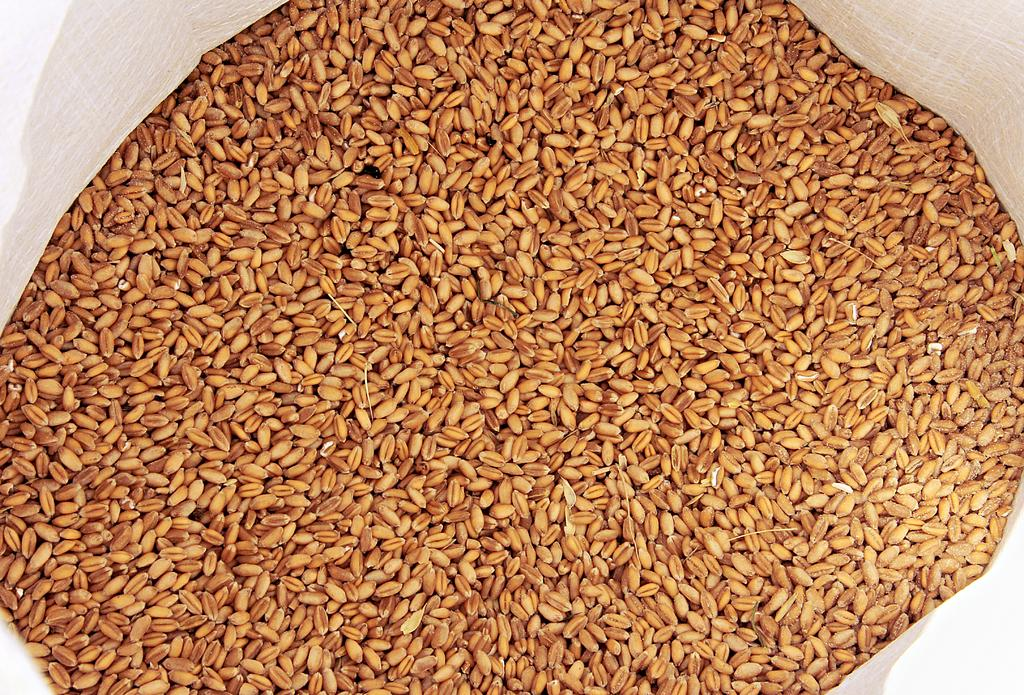What type of plants are in the foreground of the image? There are wheat plants in the foreground of the image. How are the wheat plants contained in the image? The wheat is in a white bag. What type of garden can be seen in the image? There is no garden present in the image; it features wheat plants in a white bag. What vegetables are being harvested in the image? There are no vegetables present in the image; it features wheat plants. 